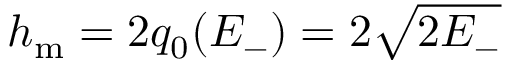<formula> <loc_0><loc_0><loc_500><loc_500>h _ { m } = 2 q _ { 0 } ( E _ { - } ) = 2 \sqrt { 2 E _ { - } }</formula> 